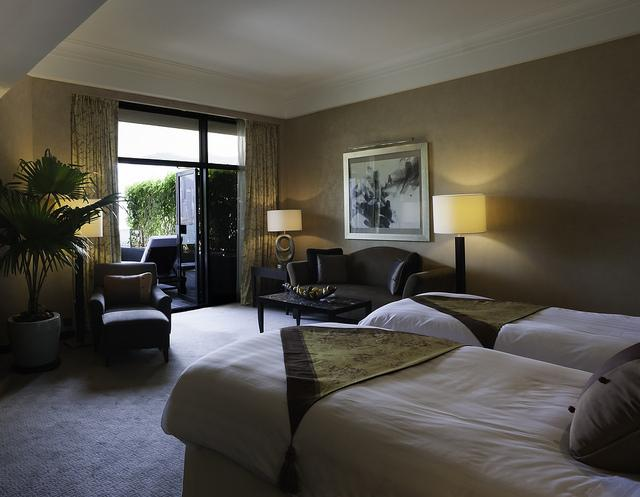What is the tray on the coffee table filled with most likely as decoration?

Choices:
A) fruit
B) candles
C) vegetables
D) blocks fruit 